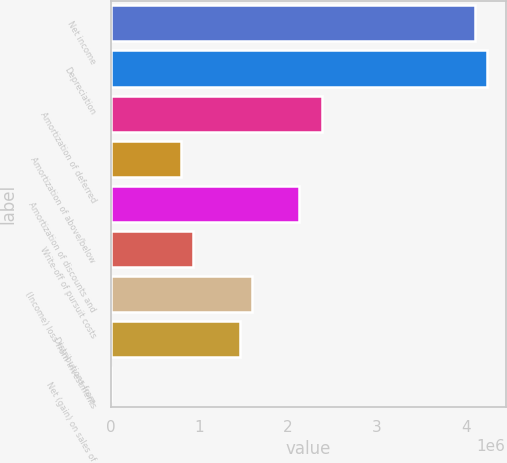Convert chart to OTSL. <chart><loc_0><loc_0><loc_500><loc_500><bar_chart><fcel>Net income<fcel>Depreciation<fcel>Amortization of deferred<fcel>Amortization of above/below<fcel>Amortization of discounts and<fcel>Write-off of pursuit costs<fcel>(Income) loss from investments<fcel>Distributions from<fcel>Net (gain) on sales of<nl><fcel>4.10451e+06<fcel>4.23691e+06<fcel>2.38329e+06<fcel>794467<fcel>2.11848e+06<fcel>926868<fcel>1.58888e+06<fcel>1.45647e+06<fcel>57<nl></chart> 